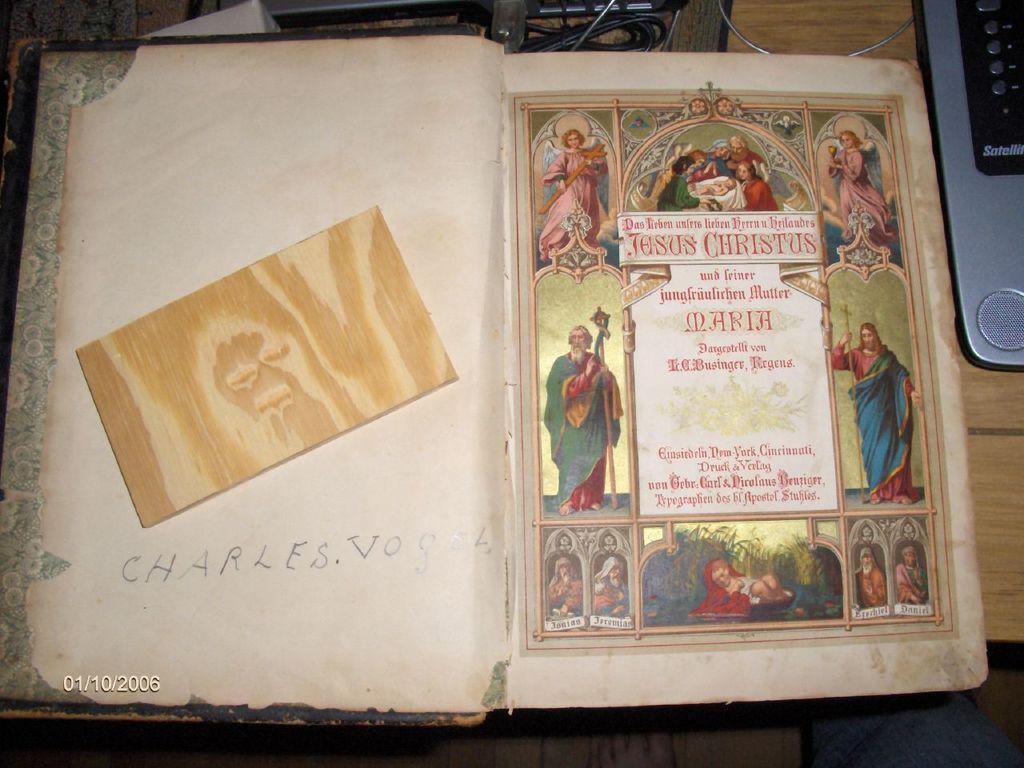What first name is written inside this book?
Provide a succinct answer. Charles. What year was this picture taken?
Ensure brevity in your answer.  2006. 